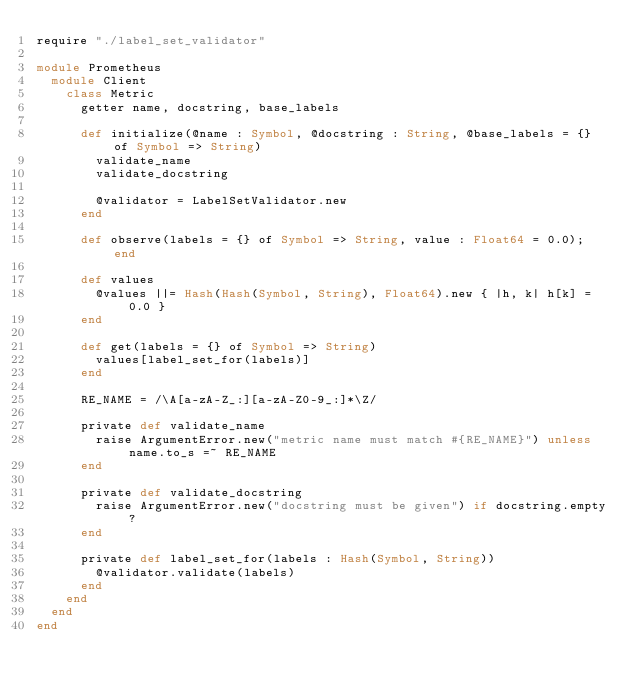<code> <loc_0><loc_0><loc_500><loc_500><_Crystal_>require "./label_set_validator"

module Prometheus
  module Client
    class Metric
      getter name, docstring, base_labels

      def initialize(@name : Symbol, @docstring : String, @base_labels = {} of Symbol => String)
        validate_name
        validate_docstring

        @validator = LabelSetValidator.new
      end

      def observe(labels = {} of Symbol => String, value : Float64 = 0.0); end

      def values
        @values ||= Hash(Hash(Symbol, String), Float64).new { |h, k| h[k] = 0.0 }
      end

      def get(labels = {} of Symbol => String)
        values[label_set_for(labels)]
      end

      RE_NAME = /\A[a-zA-Z_:][a-zA-Z0-9_:]*\Z/

      private def validate_name
        raise ArgumentError.new("metric name must match #{RE_NAME}") unless name.to_s =~ RE_NAME
      end

      private def validate_docstring
        raise ArgumentError.new("docstring must be given") if docstring.empty?
      end

      private def label_set_for(labels : Hash(Symbol, String))
        @validator.validate(labels)
      end
    end
  end
end
</code> 